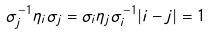Convert formula to latex. <formula><loc_0><loc_0><loc_500><loc_500>\sigma _ { j } ^ { - 1 } \eta _ { i } \sigma _ { j } = \sigma _ { i } \eta _ { j } \sigma _ { i } ^ { - 1 } | i - j | = 1</formula> 